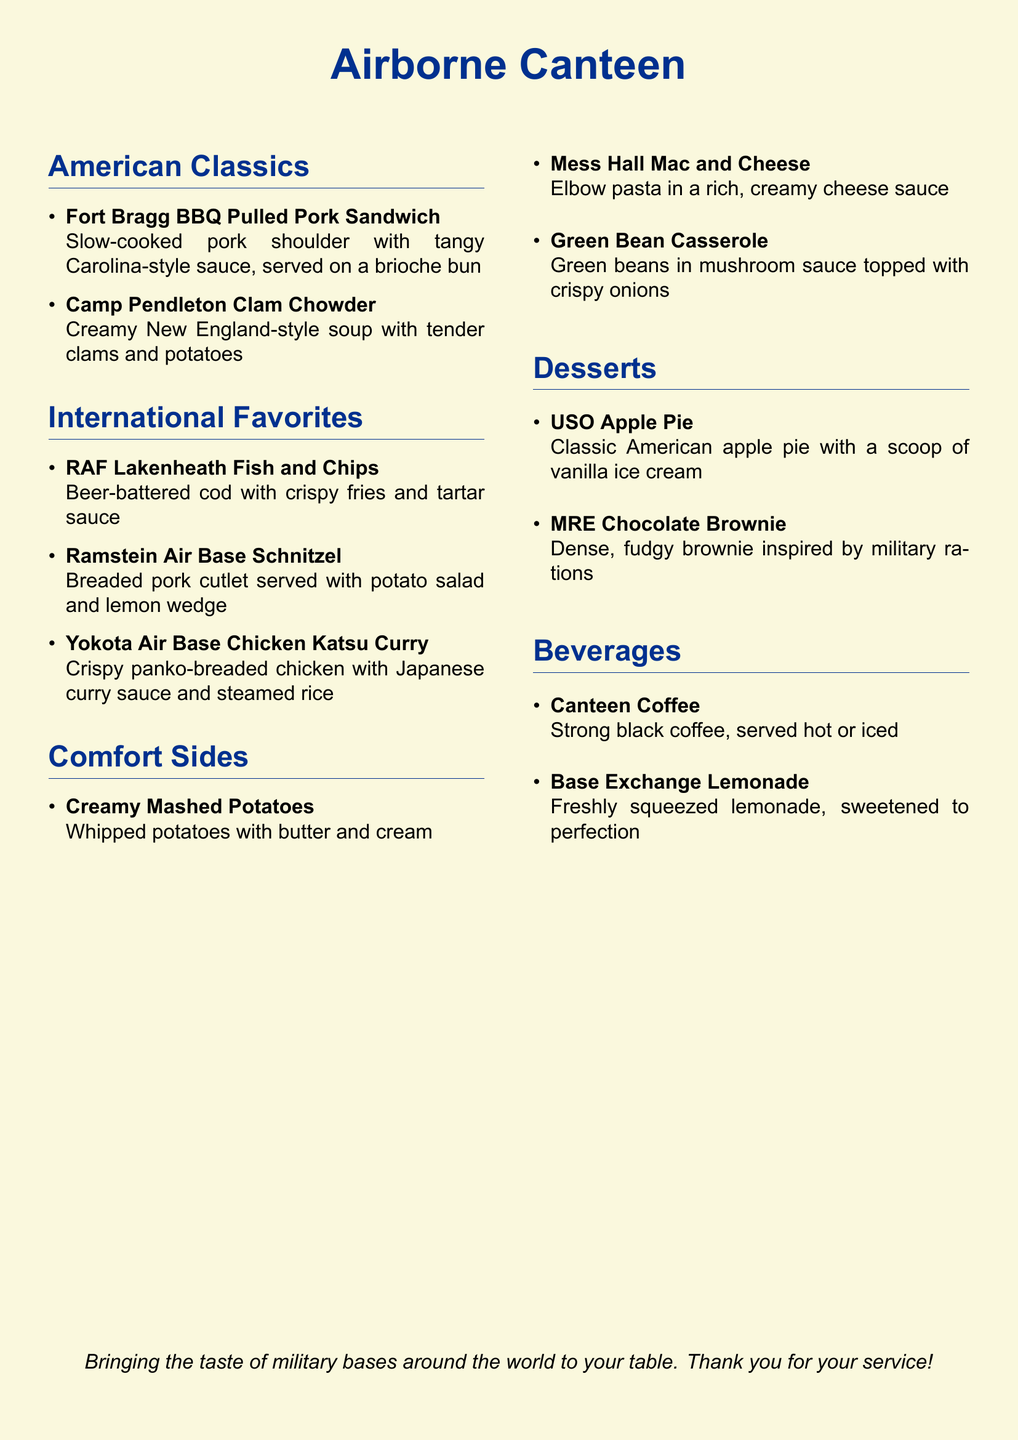What is the name of the BBQ pulled pork sandwich? The name can be found under the American Classics section, which lists "Fort Bragg BBQ Pulled Pork Sandwich."
Answer: Fort Bragg BBQ Pulled Pork Sandwich What type of soup is offered in the American Classics section? The document specifies "Camp Pendleton Clam Chowder" as the type of soup available.
Answer: Clam Chowder What is served with the Ramstein Air Base Schnitzel? The document states that potato salad and a lemon wedge accompany the Schnitzel dish.
Answer: Potato salad and lemon wedge How many desserts are listed on the menu? By counting the items in the Desserts section, a total of two desserts are mentioned.
Answer: 2 What is included in the Mess Hall Mac and Cheese? The description states that it consists of elbow pasta in a rich, creamy cheese sauce, which indicates its primary ingredients.
Answer: Elbow pasta and cheese sauce Which beverage is served strong and black? The menu specifies "Canteen Coffee" as the beverage served strong and black.
Answer: Canteen Coffee Which dish features Japanese curry sauce? The menu identifies "Yokota Air Base Chicken Katsu Curry" as the dish featuring Japanese curry sauce.
Answer: Yokota Air Base Chicken Katsu Curry What is the main ingredient in the MRE Chocolate Brownie? The description suggests that the main characteristic of the MRE Chocolate Brownie is its dense, fudgy composition.
Answer: Fudgy brownie Which section has a dish called Green Bean Casserole? The dish is located in the Comfort Sides section of the menu.
Answer: Comfort Sides 